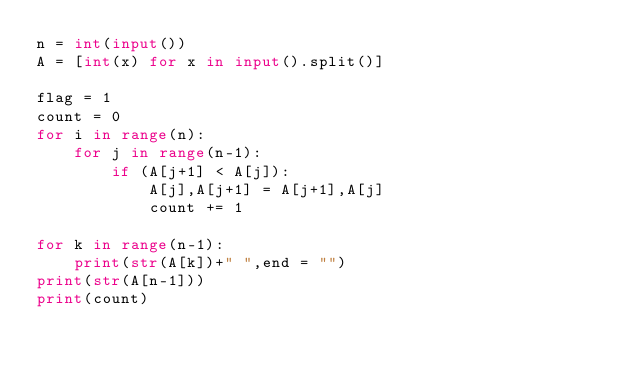<code> <loc_0><loc_0><loc_500><loc_500><_Python_>n = int(input())
A = [int(x) for x in input().split()]

flag = 1
count = 0
for i in range(n):
    for j in range(n-1):
        if (A[j+1] < A[j]):
            A[j],A[j+1] = A[j+1],A[j]
            count += 1

for k in range(n-1):
    print(str(A[k])+" ",end = "")
print(str(A[n-1]))
print(count)

</code> 